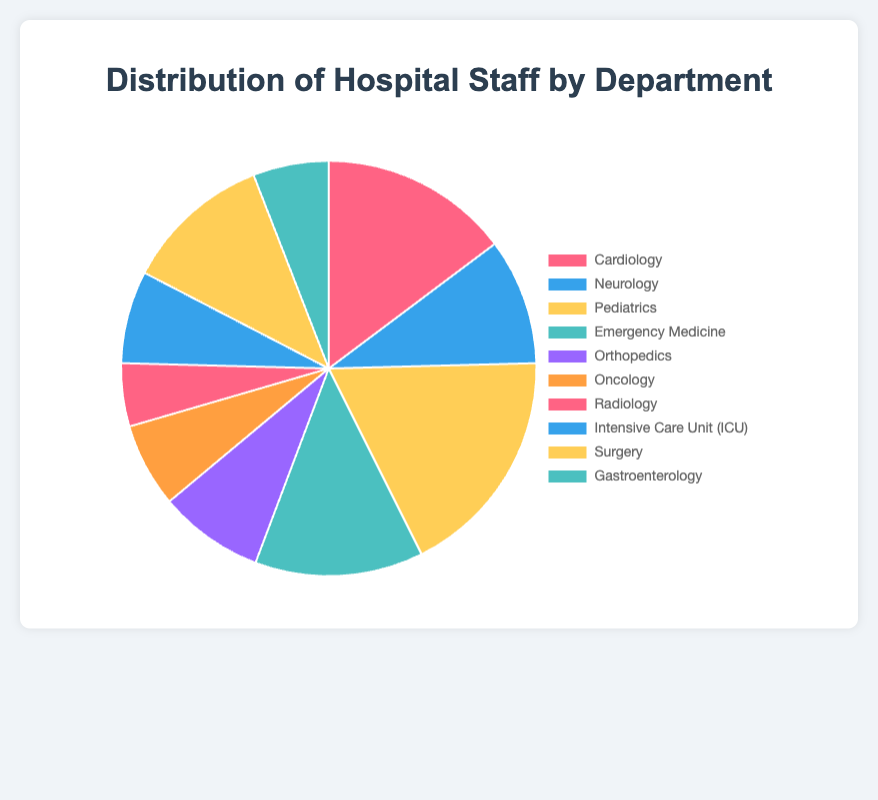Which department has the highest number of staff? The department with the largest slice in the pie chart represents the highest number of staff. In this case, it's Pediatrics.
Answer: Pediatrics Which department has the lowest number of staff? The department with the smallest slice in the pie chart represents the lowest number of staff. In this case, it's Radiology.
Answer: Radiology What is the total number of staff in the hospital? Sum the number of staff from all departments: 45 (Cardiology) + 30 (Neurology) + 55 (Pediatrics) + 40 (Emergency Medicine) + 25 (Orthopedics) + 20 (Oncology) + 15 (Radiology) + 22 (ICU) + 35 (Surgery) + 18 (Gastroenterology) = 305.
Answer: 305 How many more staff does the Pediatrics department have compared to the Oncology department? Subtract the number of staff in Oncology from the number in Pediatrics: 55 (Pediatrics) - 20 (Oncology) = 35.
Answer: 35 What's the average number of staff per department? Divide the total number of staff by the number of departments: 305 (total staff) / 10 (departments) = 30.5.
Answer: 30.5 Which departments have more than 40 staff members? Identify the departments with staff greater than 40: Cardiology (45), Pediatrics (55), Emergency Medicine (40, equivalent to 40 but included in some thresholds).
Answer: Cardiology, Pediatrics How does the number of staff in Cardiology compare to that in Surgery? Compare the number of staff in both departments: 45 (Cardiology) vs. 35 (Surgery). Cardiology has more staff.
Answer: Cardiology has more What's the percentage of total staff employed in the ICU department? Calculate the percentage: (Number of staff in ICU / Total number of staff) * 100 = (22 / 305) * 100 ≈ 7.21%.
Answer: Approximately 7.21% Which department's slice appears to be blue in color? Identify the department associated with the blue color on the pie chart. Based on the color assignments, this is Neurology.
Answer: Neurology If you combined staff from Oncology and Radiology, where would the combined total rank among the individual departments? Add the staff from Oncology and Radiology: 20 (Oncology) + 15 (Radiology) = 35. Compare this combined total to other departments: Pediatrics (55), Cardiology (45), Emergency Medicine (40), Neurology (30), Surgery (35), Orthopedics (25), Gastroenterology (18), ICU (22). The combined total ranks fifth.
Answer: Fifth 